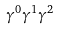<formula> <loc_0><loc_0><loc_500><loc_500>\gamma ^ { 0 } \gamma ^ { 1 } \gamma ^ { 2 }</formula> 